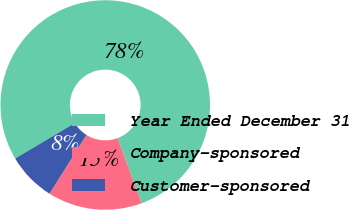<chart> <loc_0><loc_0><loc_500><loc_500><pie_chart><fcel>Year Ended December 31<fcel>Company-sponsored<fcel>Customer-sponsored<nl><fcel>77.89%<fcel>14.57%<fcel>7.54%<nl></chart> 